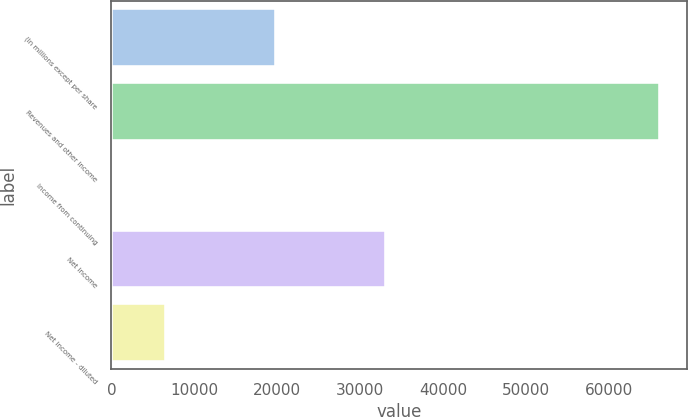Convert chart. <chart><loc_0><loc_0><loc_500><loc_500><bar_chart><fcel>(In millions except per share<fcel>Revenues and other income<fcel>Income from continuing<fcel>Net income<fcel>Net income - diluted<nl><fcel>19830.2<fcel>66089<fcel>5.03<fcel>33047<fcel>6613.43<nl></chart> 